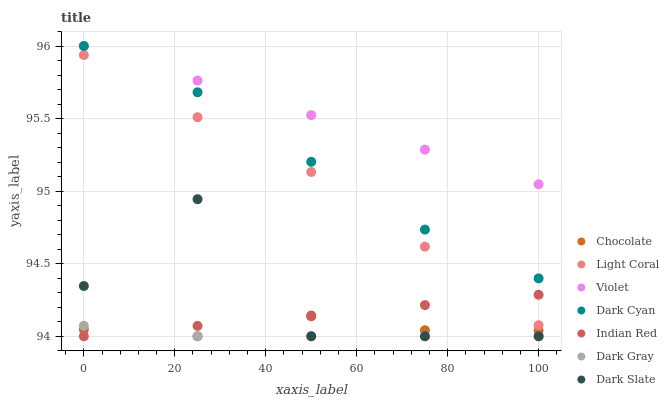Does Dark Gray have the minimum area under the curve?
Answer yes or no. Yes. Does Violet have the maximum area under the curve?
Answer yes or no. Yes. Does Chocolate have the minimum area under the curve?
Answer yes or no. No. Does Chocolate have the maximum area under the curve?
Answer yes or no. No. Is Indian Red the smoothest?
Answer yes or no. Yes. Is Dark Slate the roughest?
Answer yes or no. Yes. Is Chocolate the smoothest?
Answer yes or no. No. Is Chocolate the roughest?
Answer yes or no. No. Does Dark Gray have the lowest value?
Answer yes or no. Yes. Does Light Coral have the lowest value?
Answer yes or no. No. Does Dark Cyan have the highest value?
Answer yes or no. Yes. Does Chocolate have the highest value?
Answer yes or no. No. Is Dark Slate less than Light Coral?
Answer yes or no. Yes. Is Light Coral greater than Dark Slate?
Answer yes or no. Yes. Does Indian Red intersect Dark Slate?
Answer yes or no. Yes. Is Indian Red less than Dark Slate?
Answer yes or no. No. Is Indian Red greater than Dark Slate?
Answer yes or no. No. Does Dark Slate intersect Light Coral?
Answer yes or no. No. 